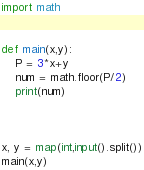Convert code to text. <code><loc_0><loc_0><loc_500><loc_500><_Python_>import math


def main(x,y):
    P = 3*x+y
    num = math.floor(P/2)
    print(num)


    
x, y = map(int,input().split())
main(x,y)
</code> 